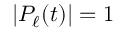<formula> <loc_0><loc_0><loc_500><loc_500>| P _ { \ell } ( t ) | = 1</formula> 